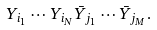<formula> <loc_0><loc_0><loc_500><loc_500>Y _ { i _ { 1 } } \cdots Y _ { i _ { N } } \bar { Y } _ { j _ { 1 } } \cdots \bar { Y } _ { j _ { M } } .</formula> 